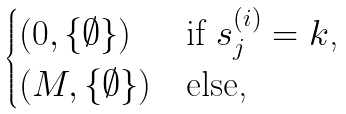Convert formula to latex. <formula><loc_0><loc_0><loc_500><loc_500>\begin{cases} \left ( 0 , \{ \emptyset \} \right ) & \text {if $s^{(i)}_{j}=k$,} \\ \left ( M , \{ \emptyset \} \right ) & \text {else,} \end{cases}</formula> 